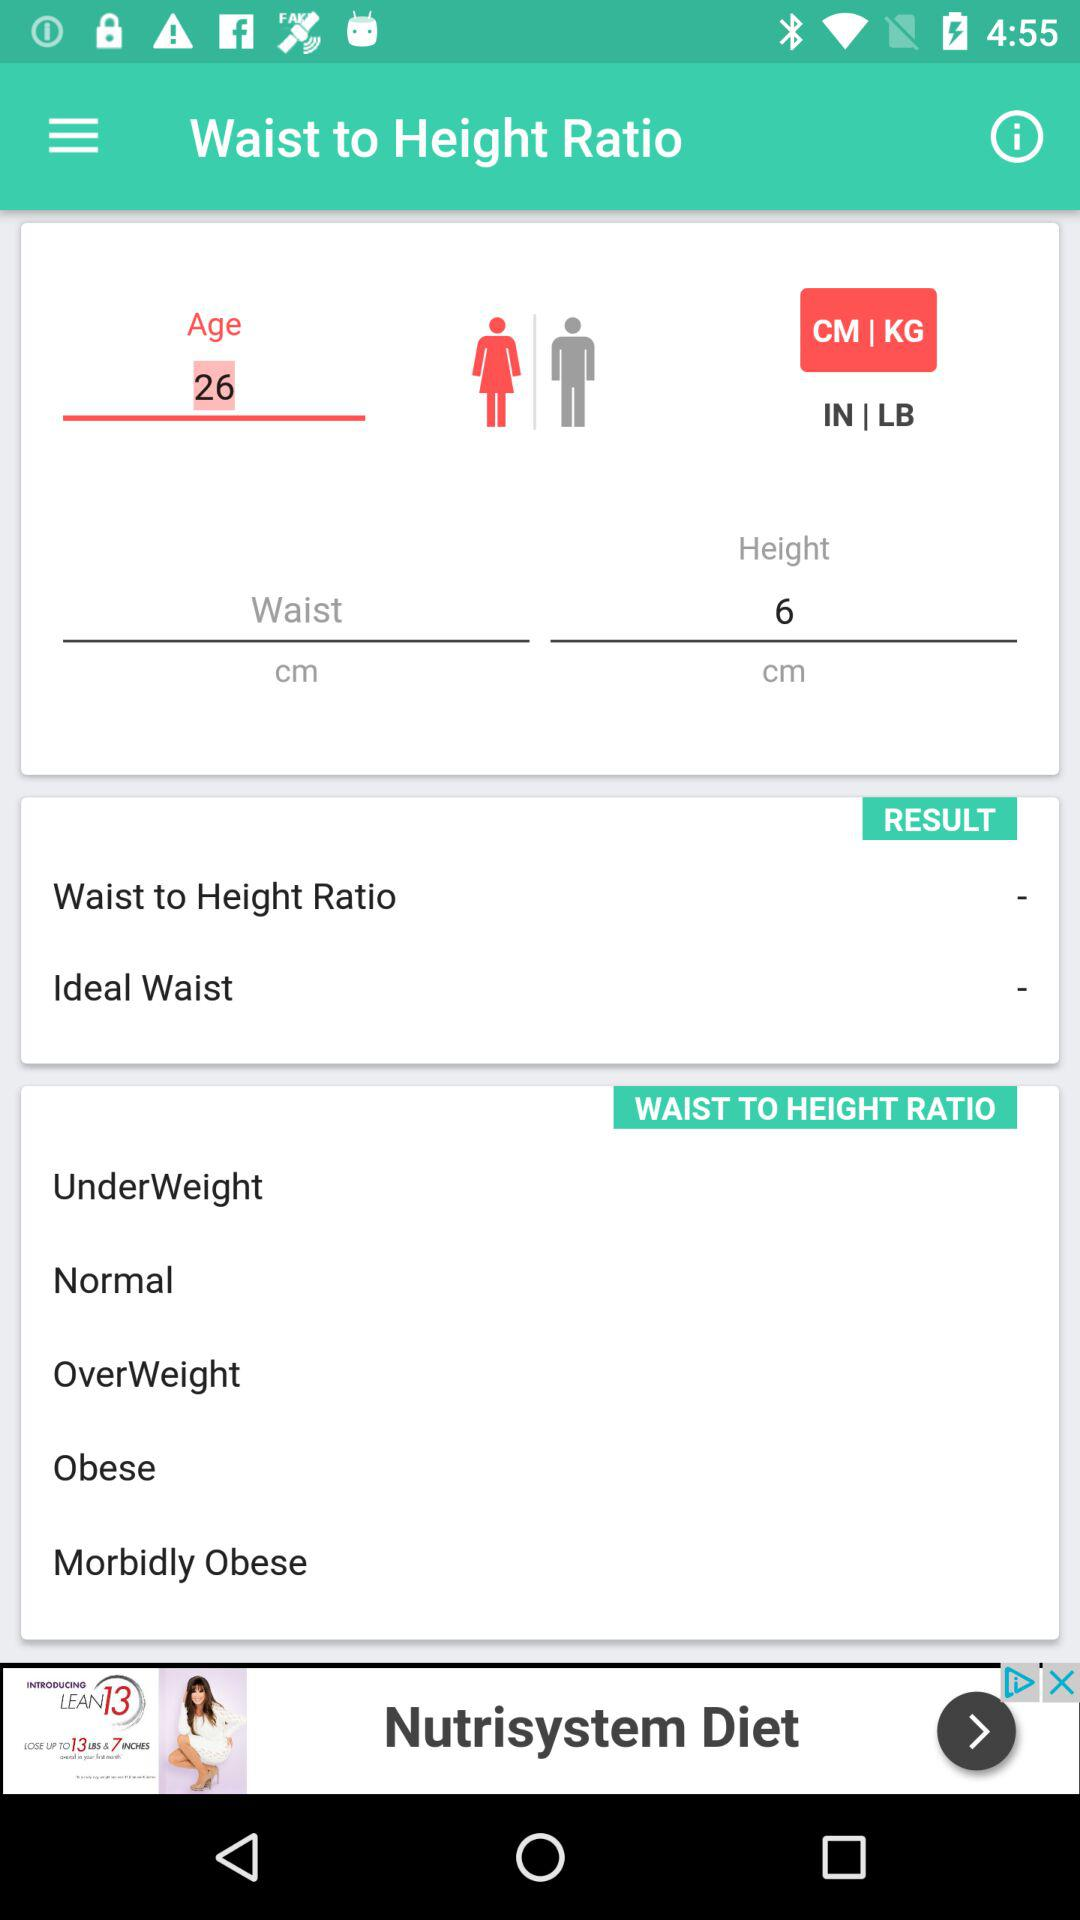What is the application name?
When the provided information is insufficient, respond with <no answer>. <no answer> 